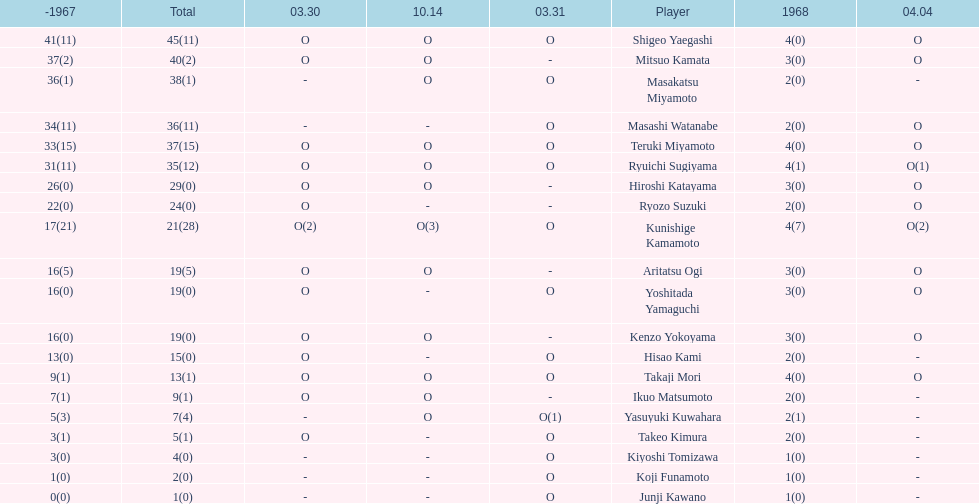Who were the players in the 1968 japanese football? Shigeo Yaegashi, Mitsuo Kamata, Masakatsu Miyamoto, Masashi Watanabe, Teruki Miyamoto, Ryuichi Sugiyama, Hiroshi Katayama, Ryozo Suzuki, Kunishige Kamamoto, Aritatsu Ogi, Yoshitada Yamaguchi, Kenzo Yokoyama, Hisao Kami, Takaji Mori, Ikuo Matsumoto, Yasuyuki Kuwahara, Takeo Kimura, Kiyoshi Tomizawa, Koji Funamoto, Junji Kawano. How many points total did takaji mori have? 13(1). How many points total did junju kawano? 1(0). Who had more points? Takaji Mori. 